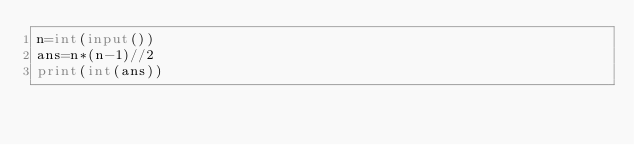Convert code to text. <code><loc_0><loc_0><loc_500><loc_500><_Python_>n=int(input())
ans=n*(n-1)//2
print(int(ans))</code> 